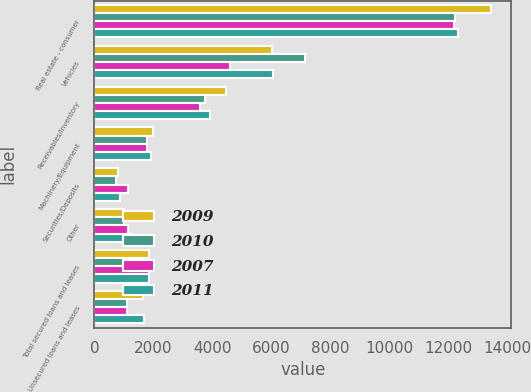<chart> <loc_0><loc_0><loc_500><loc_500><stacked_bar_chart><ecel><fcel>Real estate - consumer<fcel>Vehicles<fcel>Receivables/Inventory<fcel>Machinery/Equipment<fcel>Securities/Deposits<fcel>Other<fcel>Total secured loans and leases<fcel>Unsecured loans and leases<nl><fcel>2009<fcel>13444<fcel>6021<fcel>4450<fcel>1994<fcel>800<fcel>1018<fcel>1844<fcel>1640<nl><fcel>2010<fcel>12214<fcel>7134<fcel>3763<fcel>1766<fcel>734<fcel>990<fcel>1844<fcel>1117<nl><fcel>2007<fcel>12176<fcel>4600<fcel>3582<fcel>1772<fcel>1145<fcel>1124<fcel>1844<fcel>1106<nl><fcel>2011<fcel>12318<fcel>6063<fcel>3915<fcel>1916<fcel>862<fcel>1231<fcel>1844<fcel>1666<nl></chart> 